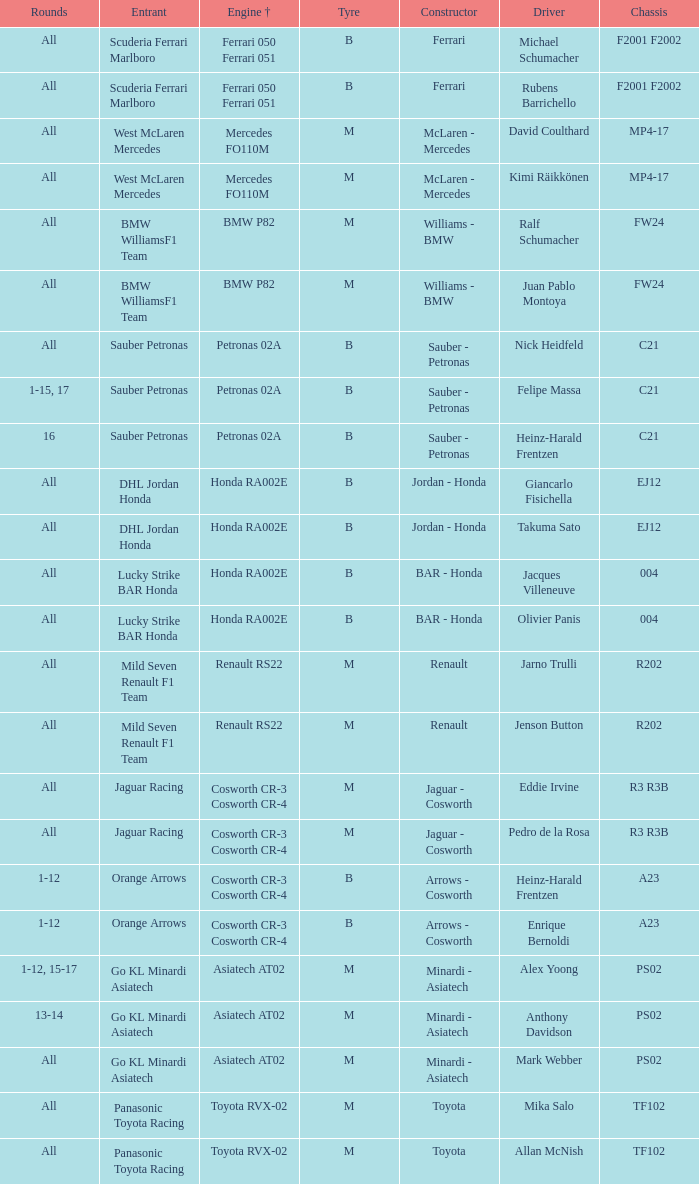What is the chassis when the tyre is b, the engine is ferrari 050 ferrari 051 and the driver is rubens barrichello? F2001 F2002. 